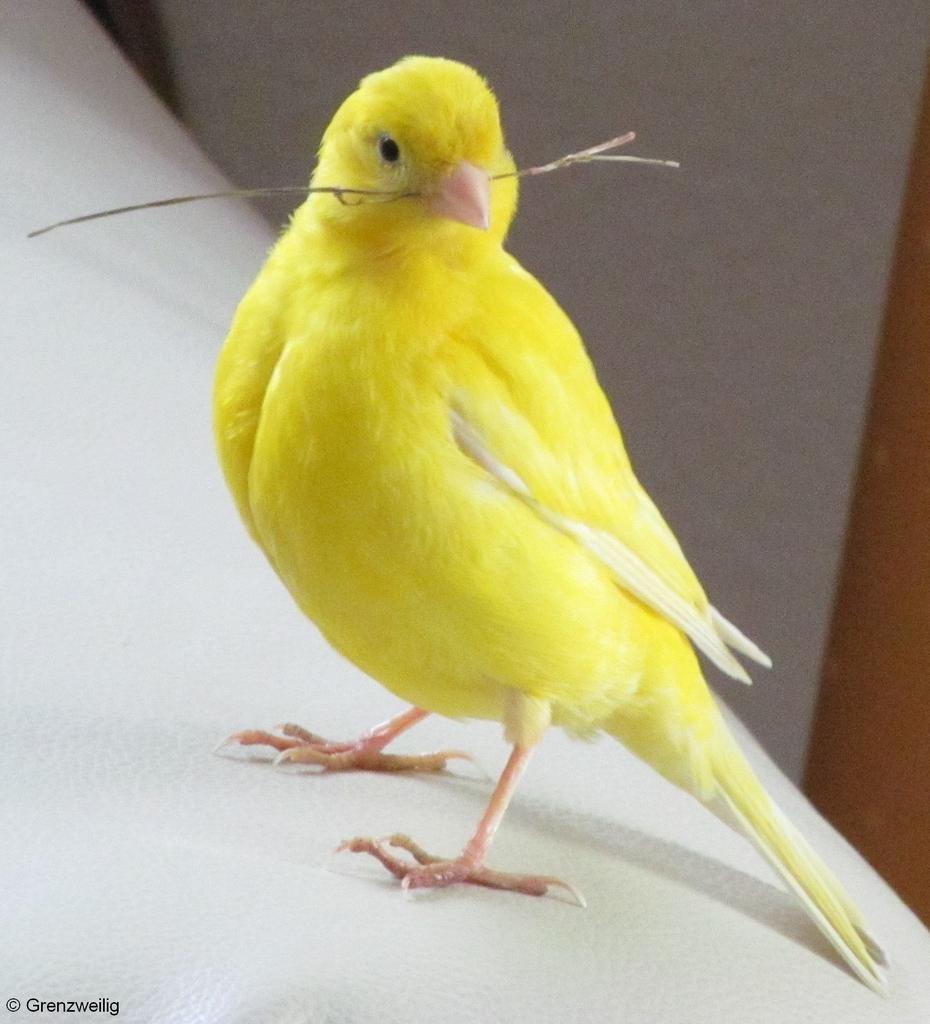Please provide a concise description of this image. This image consists of a bird in yellow color. It is holding a small stem in its mouth. It is standing on the wall. In the background, there is a wall. 